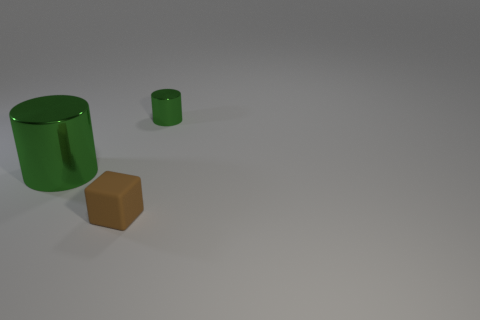What is the material of the object that is the same color as the small cylinder?
Offer a very short reply. Metal. What is the material of the green cylinder that is the same size as the rubber block?
Offer a terse response. Metal. What is the size of the green metal cylinder left of the thing on the right side of the tiny matte cube that is to the left of the small green metal cylinder?
Offer a terse response. Large. There is a cylinder in front of the tiny metallic cylinder; is its color the same as the small thing behind the big shiny object?
Provide a succinct answer. Yes. What number of brown things are either metallic things or small blocks?
Offer a very short reply. 1. What number of other brown rubber cubes have the same size as the matte block?
Give a very brief answer. 0. Do the green object that is left of the small green shiny object and the tiny brown block have the same material?
Provide a succinct answer. No. Are there any metallic cylinders that are right of the metallic object to the right of the small brown matte block?
Your response must be concise. No. What is the material of the other green thing that is the same shape as the small green metal object?
Your response must be concise. Metal. Are there more brown cubes to the left of the big green metallic thing than big metal cylinders that are in front of the brown matte object?
Provide a short and direct response. No. 